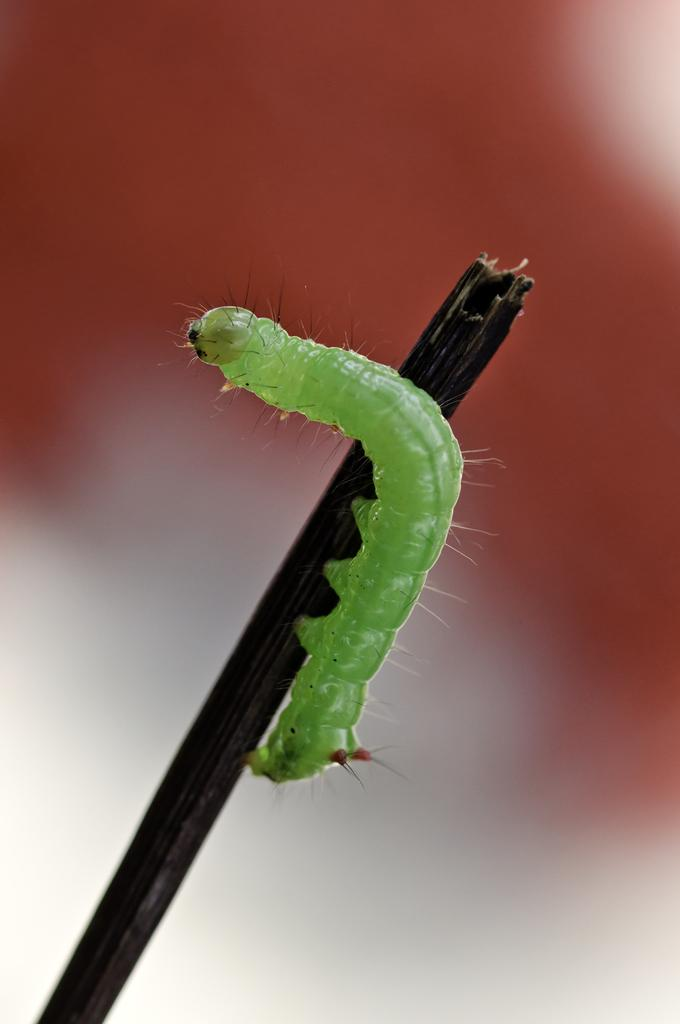What is the main subject of the image? The main subject of the image is a caterpillar. Where is the caterpillar located in the image? The caterpillar is on a stick in the middle of the image. What type of feather can be seen attached to the caterpillar in the image? There is no feather present in the image; the caterpillar is on a stick. How does the caterpillar turn around on the stick in the image? The caterpillar does not turn around in the image; it is stationary on the stick. 